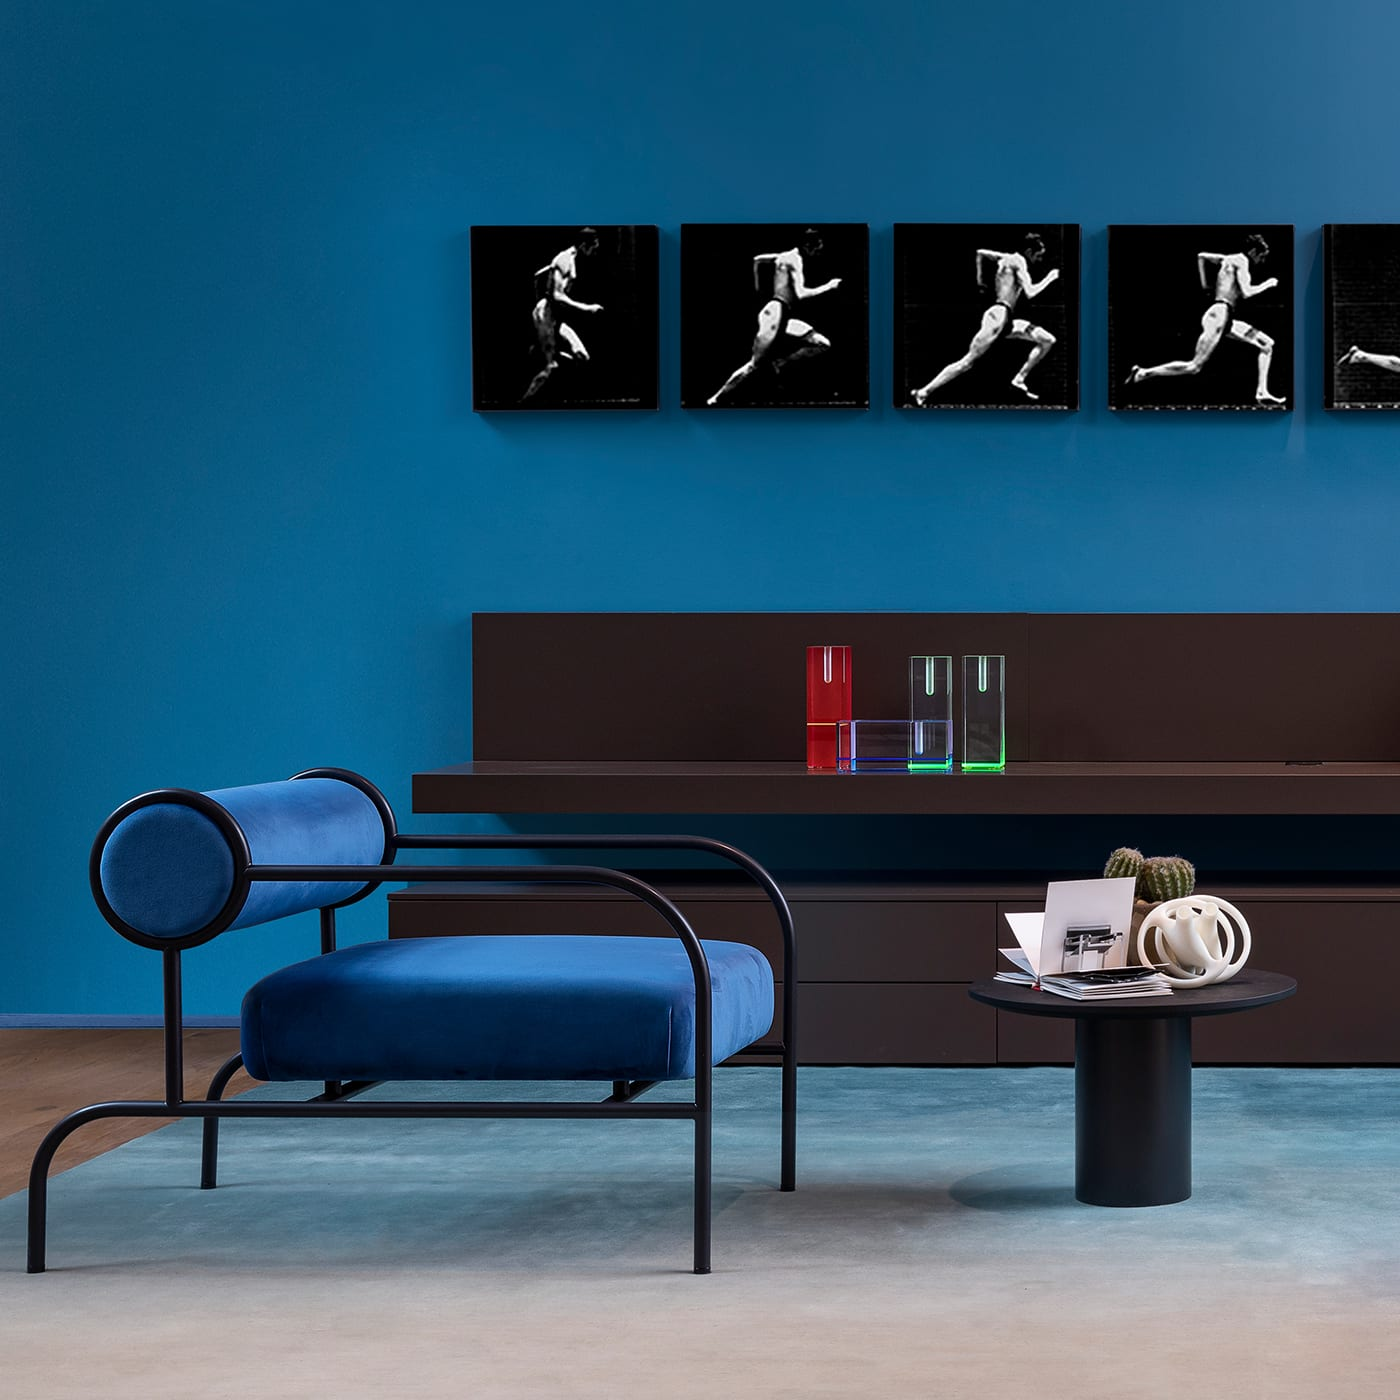How many chairs are there in the image? There is one chair visible in the image, featuring a modern design with a curved metal frame and a plush blue cushion, complementing the contemporary aesthetic of the room. 